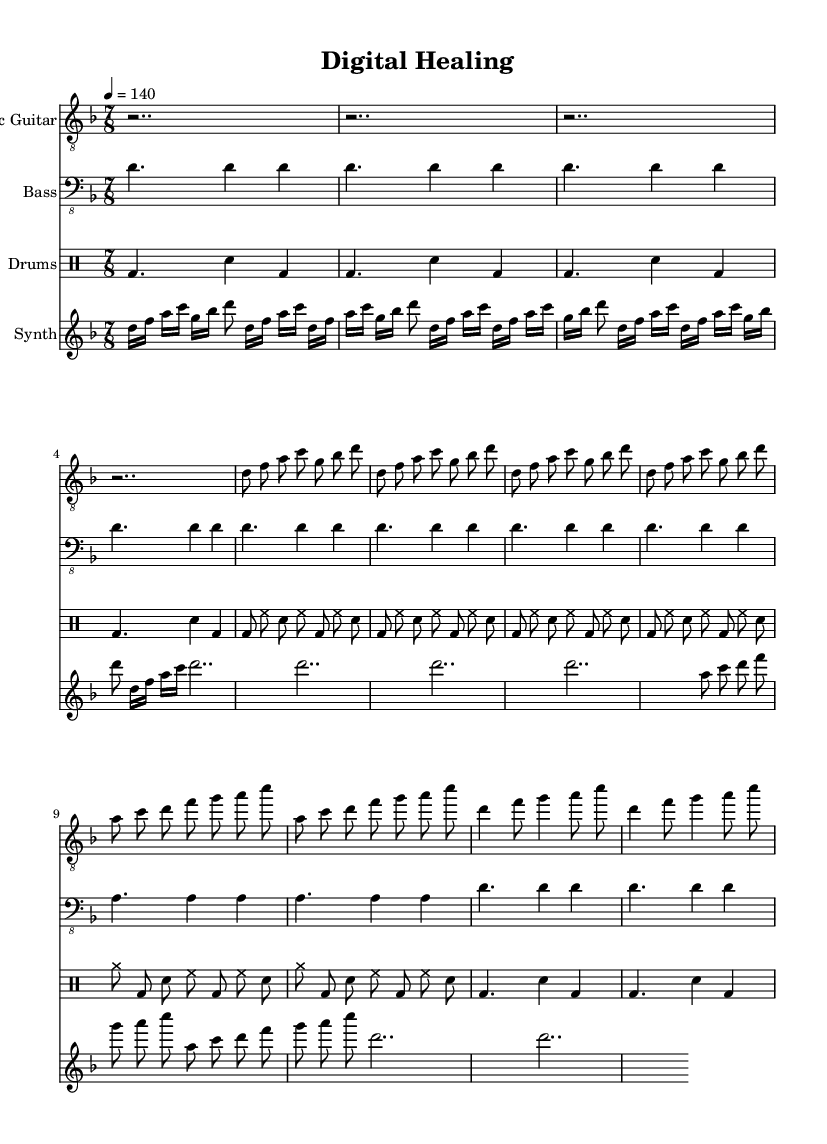What is the key signature of this music? The key signature indicates D minor, which has one flat (B flat). This can be found at the beginning of the staff.
Answer: D minor What is the time signature of this music? The time signature is 7/8, which tells us there are seven eighth notes in each measure. This is located next to the key signature at the beginning of the sheet music.
Answer: 7/8 What is the tempo marking for this piece? The tempo marking is 4 = 140, meaning that there are 140 beats per minute, with each quarter note receiving one beat. This is specified in the global section of the code.
Answer: 140 How many measures does the intro section contain? The intro section has 4 measures, as indicated by the repeated r2.. notations, representing rest for two beats in each of the four measures.
Answer: 4 measures What is the main theme conveyed by the song title? The title "Digital Healing" suggests the integration of technology into health solutions, reflecting themes relevant to both healthcare and technological advancements. This interpretation is based on the title itself and the overall concept of the music.
Answer: Technology and healthcare Which instrument plays the lead during the chorus? The electric guitar plays the lead during the chorus, as represented in the notation, and is highlighted in the musical structure of the piece.
Answer: Electric Guitar How does the bridge section differentiate from the verse? The bridge features a "clean part" with simple melodic content as opposed to the more rhythmically complex and thematic phrasing of the verse. This can be discerned from the notation differences in each section.
Answer: It has simpler melodies 